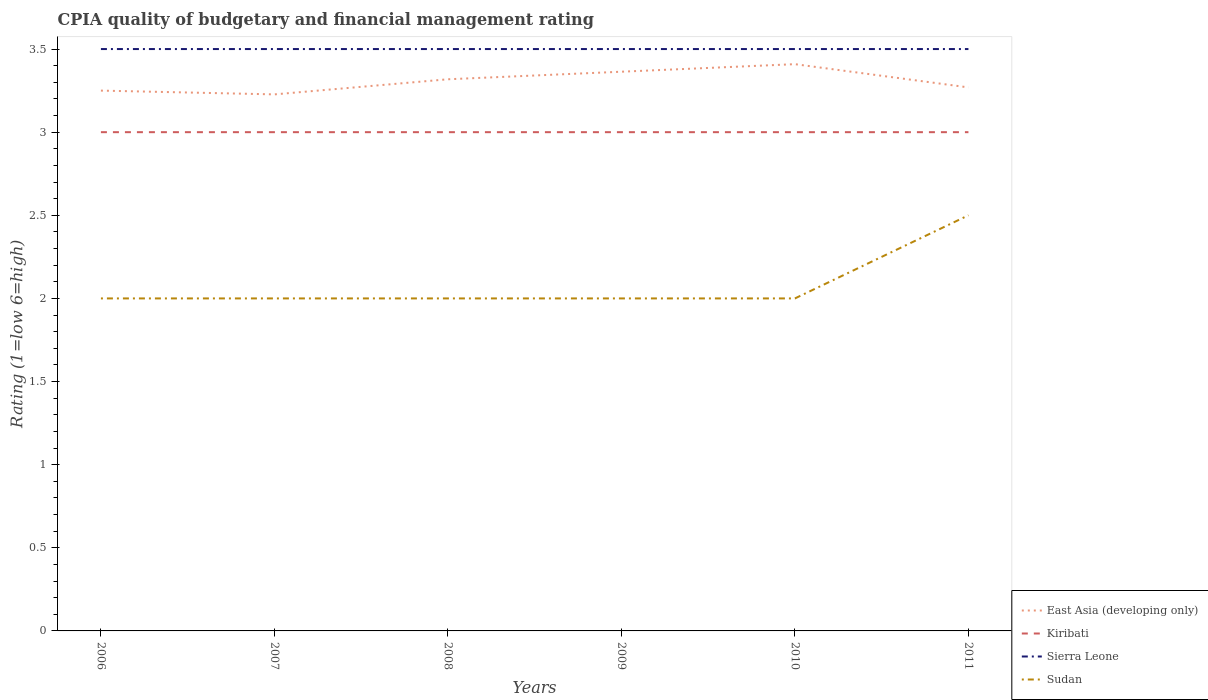What is the total CPIA rating in Sudan in the graph?
Give a very brief answer. -0.5. What is the difference between the highest and the second highest CPIA rating in East Asia (developing only)?
Offer a terse response. 0.18. What is the difference between the highest and the lowest CPIA rating in Sudan?
Your answer should be very brief. 1. How many lines are there?
Your response must be concise. 4. How many years are there in the graph?
Provide a succinct answer. 6. What is the difference between two consecutive major ticks on the Y-axis?
Your response must be concise. 0.5. Does the graph contain grids?
Your answer should be very brief. No. Where does the legend appear in the graph?
Provide a succinct answer. Bottom right. How many legend labels are there?
Offer a terse response. 4. How are the legend labels stacked?
Provide a short and direct response. Vertical. What is the title of the graph?
Provide a succinct answer. CPIA quality of budgetary and financial management rating. Does "Gambia, The" appear as one of the legend labels in the graph?
Ensure brevity in your answer.  No. What is the Rating (1=low 6=high) in Sudan in 2006?
Your answer should be compact. 2. What is the Rating (1=low 6=high) of East Asia (developing only) in 2007?
Ensure brevity in your answer.  3.23. What is the Rating (1=low 6=high) of Kiribati in 2007?
Provide a succinct answer. 3. What is the Rating (1=low 6=high) of Sierra Leone in 2007?
Make the answer very short. 3.5. What is the Rating (1=low 6=high) in East Asia (developing only) in 2008?
Offer a terse response. 3.32. What is the Rating (1=low 6=high) in Sierra Leone in 2008?
Offer a terse response. 3.5. What is the Rating (1=low 6=high) in East Asia (developing only) in 2009?
Offer a terse response. 3.36. What is the Rating (1=low 6=high) of Sierra Leone in 2009?
Offer a very short reply. 3.5. What is the Rating (1=low 6=high) of Sudan in 2009?
Provide a short and direct response. 2. What is the Rating (1=low 6=high) of East Asia (developing only) in 2010?
Offer a terse response. 3.41. What is the Rating (1=low 6=high) in Kiribati in 2010?
Make the answer very short. 3. What is the Rating (1=low 6=high) of Sudan in 2010?
Offer a very short reply. 2. What is the Rating (1=low 6=high) in East Asia (developing only) in 2011?
Offer a terse response. 3.27. What is the Rating (1=low 6=high) of Sierra Leone in 2011?
Offer a terse response. 3.5. What is the Rating (1=low 6=high) of Sudan in 2011?
Offer a terse response. 2.5. Across all years, what is the maximum Rating (1=low 6=high) of East Asia (developing only)?
Provide a short and direct response. 3.41. Across all years, what is the maximum Rating (1=low 6=high) in Sudan?
Provide a short and direct response. 2.5. Across all years, what is the minimum Rating (1=low 6=high) in East Asia (developing only)?
Offer a very short reply. 3.23. Across all years, what is the minimum Rating (1=low 6=high) of Sudan?
Your answer should be compact. 2. What is the total Rating (1=low 6=high) of East Asia (developing only) in the graph?
Your answer should be compact. 19.84. What is the difference between the Rating (1=low 6=high) of East Asia (developing only) in 2006 and that in 2007?
Provide a succinct answer. 0.02. What is the difference between the Rating (1=low 6=high) of Kiribati in 2006 and that in 2007?
Provide a short and direct response. 0. What is the difference between the Rating (1=low 6=high) of East Asia (developing only) in 2006 and that in 2008?
Offer a very short reply. -0.07. What is the difference between the Rating (1=low 6=high) in Sierra Leone in 2006 and that in 2008?
Give a very brief answer. 0. What is the difference between the Rating (1=low 6=high) of Sudan in 2006 and that in 2008?
Provide a succinct answer. 0. What is the difference between the Rating (1=low 6=high) in East Asia (developing only) in 2006 and that in 2009?
Provide a succinct answer. -0.11. What is the difference between the Rating (1=low 6=high) in Kiribati in 2006 and that in 2009?
Give a very brief answer. 0. What is the difference between the Rating (1=low 6=high) in Sierra Leone in 2006 and that in 2009?
Your answer should be compact. 0. What is the difference between the Rating (1=low 6=high) in East Asia (developing only) in 2006 and that in 2010?
Your answer should be compact. -0.16. What is the difference between the Rating (1=low 6=high) of Sierra Leone in 2006 and that in 2010?
Offer a terse response. 0. What is the difference between the Rating (1=low 6=high) of East Asia (developing only) in 2006 and that in 2011?
Your answer should be compact. -0.02. What is the difference between the Rating (1=low 6=high) of Sierra Leone in 2006 and that in 2011?
Make the answer very short. 0. What is the difference between the Rating (1=low 6=high) of Sudan in 2006 and that in 2011?
Provide a short and direct response. -0.5. What is the difference between the Rating (1=low 6=high) of East Asia (developing only) in 2007 and that in 2008?
Your answer should be compact. -0.09. What is the difference between the Rating (1=low 6=high) in East Asia (developing only) in 2007 and that in 2009?
Provide a short and direct response. -0.14. What is the difference between the Rating (1=low 6=high) of Kiribati in 2007 and that in 2009?
Your answer should be very brief. 0. What is the difference between the Rating (1=low 6=high) in East Asia (developing only) in 2007 and that in 2010?
Ensure brevity in your answer.  -0.18. What is the difference between the Rating (1=low 6=high) of Kiribati in 2007 and that in 2010?
Provide a short and direct response. 0. What is the difference between the Rating (1=low 6=high) of Sierra Leone in 2007 and that in 2010?
Offer a very short reply. 0. What is the difference between the Rating (1=low 6=high) of East Asia (developing only) in 2007 and that in 2011?
Your answer should be very brief. -0.04. What is the difference between the Rating (1=low 6=high) of East Asia (developing only) in 2008 and that in 2009?
Give a very brief answer. -0.05. What is the difference between the Rating (1=low 6=high) of Kiribati in 2008 and that in 2009?
Your answer should be very brief. 0. What is the difference between the Rating (1=low 6=high) of Sierra Leone in 2008 and that in 2009?
Make the answer very short. 0. What is the difference between the Rating (1=low 6=high) of Sudan in 2008 and that in 2009?
Give a very brief answer. 0. What is the difference between the Rating (1=low 6=high) in East Asia (developing only) in 2008 and that in 2010?
Ensure brevity in your answer.  -0.09. What is the difference between the Rating (1=low 6=high) of Kiribati in 2008 and that in 2010?
Your answer should be compact. 0. What is the difference between the Rating (1=low 6=high) of Sierra Leone in 2008 and that in 2010?
Make the answer very short. 0. What is the difference between the Rating (1=low 6=high) of Sudan in 2008 and that in 2010?
Make the answer very short. 0. What is the difference between the Rating (1=low 6=high) in East Asia (developing only) in 2008 and that in 2011?
Keep it short and to the point. 0.05. What is the difference between the Rating (1=low 6=high) of Sierra Leone in 2008 and that in 2011?
Make the answer very short. 0. What is the difference between the Rating (1=low 6=high) of East Asia (developing only) in 2009 and that in 2010?
Offer a terse response. -0.05. What is the difference between the Rating (1=low 6=high) of Kiribati in 2009 and that in 2010?
Your answer should be very brief. 0. What is the difference between the Rating (1=low 6=high) in Sierra Leone in 2009 and that in 2010?
Make the answer very short. 0. What is the difference between the Rating (1=low 6=high) in Sudan in 2009 and that in 2010?
Keep it short and to the point. 0. What is the difference between the Rating (1=low 6=high) in East Asia (developing only) in 2009 and that in 2011?
Offer a terse response. 0.09. What is the difference between the Rating (1=low 6=high) in Kiribati in 2009 and that in 2011?
Offer a very short reply. 0. What is the difference between the Rating (1=low 6=high) in Sierra Leone in 2009 and that in 2011?
Your answer should be compact. 0. What is the difference between the Rating (1=low 6=high) in East Asia (developing only) in 2010 and that in 2011?
Ensure brevity in your answer.  0.14. What is the difference between the Rating (1=low 6=high) in Kiribati in 2010 and that in 2011?
Offer a terse response. 0. What is the difference between the Rating (1=low 6=high) in Sudan in 2010 and that in 2011?
Offer a very short reply. -0.5. What is the difference between the Rating (1=low 6=high) of East Asia (developing only) in 2006 and the Rating (1=low 6=high) of Kiribati in 2007?
Offer a terse response. 0.25. What is the difference between the Rating (1=low 6=high) in East Asia (developing only) in 2006 and the Rating (1=low 6=high) in Sierra Leone in 2007?
Make the answer very short. -0.25. What is the difference between the Rating (1=low 6=high) in Kiribati in 2006 and the Rating (1=low 6=high) in Sierra Leone in 2007?
Provide a succinct answer. -0.5. What is the difference between the Rating (1=low 6=high) of Kiribati in 2006 and the Rating (1=low 6=high) of Sudan in 2007?
Make the answer very short. 1. What is the difference between the Rating (1=low 6=high) in Sierra Leone in 2006 and the Rating (1=low 6=high) in Sudan in 2007?
Provide a short and direct response. 1.5. What is the difference between the Rating (1=low 6=high) of East Asia (developing only) in 2006 and the Rating (1=low 6=high) of Kiribati in 2008?
Offer a very short reply. 0.25. What is the difference between the Rating (1=low 6=high) of Kiribati in 2006 and the Rating (1=low 6=high) of Sierra Leone in 2008?
Provide a succinct answer. -0.5. What is the difference between the Rating (1=low 6=high) in Kiribati in 2006 and the Rating (1=low 6=high) in Sudan in 2008?
Keep it short and to the point. 1. What is the difference between the Rating (1=low 6=high) in Sierra Leone in 2006 and the Rating (1=low 6=high) in Sudan in 2008?
Provide a short and direct response. 1.5. What is the difference between the Rating (1=low 6=high) in East Asia (developing only) in 2006 and the Rating (1=low 6=high) in Kiribati in 2009?
Provide a short and direct response. 0.25. What is the difference between the Rating (1=low 6=high) in East Asia (developing only) in 2006 and the Rating (1=low 6=high) in Sierra Leone in 2009?
Provide a succinct answer. -0.25. What is the difference between the Rating (1=low 6=high) of Sierra Leone in 2006 and the Rating (1=low 6=high) of Sudan in 2009?
Ensure brevity in your answer.  1.5. What is the difference between the Rating (1=low 6=high) in East Asia (developing only) in 2006 and the Rating (1=low 6=high) in Kiribati in 2010?
Provide a short and direct response. 0.25. What is the difference between the Rating (1=low 6=high) of East Asia (developing only) in 2006 and the Rating (1=low 6=high) of Sudan in 2010?
Your response must be concise. 1.25. What is the difference between the Rating (1=low 6=high) of Kiribati in 2006 and the Rating (1=low 6=high) of Sierra Leone in 2010?
Your answer should be compact. -0.5. What is the difference between the Rating (1=low 6=high) of East Asia (developing only) in 2006 and the Rating (1=low 6=high) of Sierra Leone in 2011?
Offer a terse response. -0.25. What is the difference between the Rating (1=low 6=high) in East Asia (developing only) in 2006 and the Rating (1=low 6=high) in Sudan in 2011?
Ensure brevity in your answer.  0.75. What is the difference between the Rating (1=low 6=high) of Kiribati in 2006 and the Rating (1=low 6=high) of Sudan in 2011?
Offer a terse response. 0.5. What is the difference between the Rating (1=low 6=high) of Sierra Leone in 2006 and the Rating (1=low 6=high) of Sudan in 2011?
Give a very brief answer. 1. What is the difference between the Rating (1=low 6=high) in East Asia (developing only) in 2007 and the Rating (1=low 6=high) in Kiribati in 2008?
Offer a very short reply. 0.23. What is the difference between the Rating (1=low 6=high) in East Asia (developing only) in 2007 and the Rating (1=low 6=high) in Sierra Leone in 2008?
Your response must be concise. -0.27. What is the difference between the Rating (1=low 6=high) of East Asia (developing only) in 2007 and the Rating (1=low 6=high) of Sudan in 2008?
Your response must be concise. 1.23. What is the difference between the Rating (1=low 6=high) of East Asia (developing only) in 2007 and the Rating (1=low 6=high) of Kiribati in 2009?
Your answer should be compact. 0.23. What is the difference between the Rating (1=low 6=high) in East Asia (developing only) in 2007 and the Rating (1=low 6=high) in Sierra Leone in 2009?
Give a very brief answer. -0.27. What is the difference between the Rating (1=low 6=high) of East Asia (developing only) in 2007 and the Rating (1=low 6=high) of Sudan in 2009?
Your answer should be compact. 1.23. What is the difference between the Rating (1=low 6=high) in Kiribati in 2007 and the Rating (1=low 6=high) in Sierra Leone in 2009?
Your answer should be very brief. -0.5. What is the difference between the Rating (1=low 6=high) in East Asia (developing only) in 2007 and the Rating (1=low 6=high) in Kiribati in 2010?
Provide a succinct answer. 0.23. What is the difference between the Rating (1=low 6=high) in East Asia (developing only) in 2007 and the Rating (1=low 6=high) in Sierra Leone in 2010?
Your response must be concise. -0.27. What is the difference between the Rating (1=low 6=high) of East Asia (developing only) in 2007 and the Rating (1=low 6=high) of Sudan in 2010?
Offer a terse response. 1.23. What is the difference between the Rating (1=low 6=high) in Sierra Leone in 2007 and the Rating (1=low 6=high) in Sudan in 2010?
Keep it short and to the point. 1.5. What is the difference between the Rating (1=low 6=high) in East Asia (developing only) in 2007 and the Rating (1=low 6=high) in Kiribati in 2011?
Keep it short and to the point. 0.23. What is the difference between the Rating (1=low 6=high) of East Asia (developing only) in 2007 and the Rating (1=low 6=high) of Sierra Leone in 2011?
Your response must be concise. -0.27. What is the difference between the Rating (1=low 6=high) of East Asia (developing only) in 2007 and the Rating (1=low 6=high) of Sudan in 2011?
Your answer should be very brief. 0.73. What is the difference between the Rating (1=low 6=high) of Kiribati in 2007 and the Rating (1=low 6=high) of Sudan in 2011?
Give a very brief answer. 0.5. What is the difference between the Rating (1=low 6=high) in Sierra Leone in 2007 and the Rating (1=low 6=high) in Sudan in 2011?
Your answer should be compact. 1. What is the difference between the Rating (1=low 6=high) of East Asia (developing only) in 2008 and the Rating (1=low 6=high) of Kiribati in 2009?
Your answer should be very brief. 0.32. What is the difference between the Rating (1=low 6=high) in East Asia (developing only) in 2008 and the Rating (1=low 6=high) in Sierra Leone in 2009?
Make the answer very short. -0.18. What is the difference between the Rating (1=low 6=high) of East Asia (developing only) in 2008 and the Rating (1=low 6=high) of Sudan in 2009?
Offer a very short reply. 1.32. What is the difference between the Rating (1=low 6=high) of Kiribati in 2008 and the Rating (1=low 6=high) of Sudan in 2009?
Your answer should be compact. 1. What is the difference between the Rating (1=low 6=high) of East Asia (developing only) in 2008 and the Rating (1=low 6=high) of Kiribati in 2010?
Give a very brief answer. 0.32. What is the difference between the Rating (1=low 6=high) of East Asia (developing only) in 2008 and the Rating (1=low 6=high) of Sierra Leone in 2010?
Give a very brief answer. -0.18. What is the difference between the Rating (1=low 6=high) in East Asia (developing only) in 2008 and the Rating (1=low 6=high) in Sudan in 2010?
Make the answer very short. 1.32. What is the difference between the Rating (1=low 6=high) of Kiribati in 2008 and the Rating (1=low 6=high) of Sierra Leone in 2010?
Make the answer very short. -0.5. What is the difference between the Rating (1=low 6=high) in East Asia (developing only) in 2008 and the Rating (1=low 6=high) in Kiribati in 2011?
Provide a short and direct response. 0.32. What is the difference between the Rating (1=low 6=high) in East Asia (developing only) in 2008 and the Rating (1=low 6=high) in Sierra Leone in 2011?
Make the answer very short. -0.18. What is the difference between the Rating (1=low 6=high) of East Asia (developing only) in 2008 and the Rating (1=low 6=high) of Sudan in 2011?
Provide a short and direct response. 0.82. What is the difference between the Rating (1=low 6=high) of Kiribati in 2008 and the Rating (1=low 6=high) of Sierra Leone in 2011?
Your answer should be very brief. -0.5. What is the difference between the Rating (1=low 6=high) of East Asia (developing only) in 2009 and the Rating (1=low 6=high) of Kiribati in 2010?
Give a very brief answer. 0.36. What is the difference between the Rating (1=low 6=high) of East Asia (developing only) in 2009 and the Rating (1=low 6=high) of Sierra Leone in 2010?
Keep it short and to the point. -0.14. What is the difference between the Rating (1=low 6=high) in East Asia (developing only) in 2009 and the Rating (1=low 6=high) in Sudan in 2010?
Your response must be concise. 1.36. What is the difference between the Rating (1=low 6=high) in Kiribati in 2009 and the Rating (1=low 6=high) in Sierra Leone in 2010?
Offer a very short reply. -0.5. What is the difference between the Rating (1=low 6=high) in Sierra Leone in 2009 and the Rating (1=low 6=high) in Sudan in 2010?
Provide a succinct answer. 1.5. What is the difference between the Rating (1=low 6=high) in East Asia (developing only) in 2009 and the Rating (1=low 6=high) in Kiribati in 2011?
Your response must be concise. 0.36. What is the difference between the Rating (1=low 6=high) in East Asia (developing only) in 2009 and the Rating (1=low 6=high) in Sierra Leone in 2011?
Make the answer very short. -0.14. What is the difference between the Rating (1=low 6=high) of East Asia (developing only) in 2009 and the Rating (1=low 6=high) of Sudan in 2011?
Your response must be concise. 0.86. What is the difference between the Rating (1=low 6=high) of Kiribati in 2009 and the Rating (1=low 6=high) of Sudan in 2011?
Offer a terse response. 0.5. What is the difference between the Rating (1=low 6=high) in Sierra Leone in 2009 and the Rating (1=low 6=high) in Sudan in 2011?
Your response must be concise. 1. What is the difference between the Rating (1=low 6=high) in East Asia (developing only) in 2010 and the Rating (1=low 6=high) in Kiribati in 2011?
Ensure brevity in your answer.  0.41. What is the difference between the Rating (1=low 6=high) in East Asia (developing only) in 2010 and the Rating (1=low 6=high) in Sierra Leone in 2011?
Your response must be concise. -0.09. What is the difference between the Rating (1=low 6=high) of East Asia (developing only) in 2010 and the Rating (1=low 6=high) of Sudan in 2011?
Your answer should be very brief. 0.91. What is the difference between the Rating (1=low 6=high) in Kiribati in 2010 and the Rating (1=low 6=high) in Sierra Leone in 2011?
Offer a very short reply. -0.5. What is the difference between the Rating (1=low 6=high) in Kiribati in 2010 and the Rating (1=low 6=high) in Sudan in 2011?
Make the answer very short. 0.5. What is the average Rating (1=low 6=high) in East Asia (developing only) per year?
Offer a terse response. 3.31. What is the average Rating (1=low 6=high) in Sierra Leone per year?
Your answer should be very brief. 3.5. What is the average Rating (1=low 6=high) in Sudan per year?
Your answer should be very brief. 2.08. In the year 2006, what is the difference between the Rating (1=low 6=high) of East Asia (developing only) and Rating (1=low 6=high) of Sierra Leone?
Offer a very short reply. -0.25. In the year 2006, what is the difference between the Rating (1=low 6=high) in Kiribati and Rating (1=low 6=high) in Sudan?
Your answer should be compact. 1. In the year 2006, what is the difference between the Rating (1=low 6=high) in Sierra Leone and Rating (1=low 6=high) in Sudan?
Your answer should be very brief. 1.5. In the year 2007, what is the difference between the Rating (1=low 6=high) of East Asia (developing only) and Rating (1=low 6=high) of Kiribati?
Offer a terse response. 0.23. In the year 2007, what is the difference between the Rating (1=low 6=high) in East Asia (developing only) and Rating (1=low 6=high) in Sierra Leone?
Offer a very short reply. -0.27. In the year 2007, what is the difference between the Rating (1=low 6=high) in East Asia (developing only) and Rating (1=low 6=high) in Sudan?
Provide a succinct answer. 1.23. In the year 2007, what is the difference between the Rating (1=low 6=high) of Kiribati and Rating (1=low 6=high) of Sudan?
Give a very brief answer. 1. In the year 2007, what is the difference between the Rating (1=low 6=high) of Sierra Leone and Rating (1=low 6=high) of Sudan?
Offer a terse response. 1.5. In the year 2008, what is the difference between the Rating (1=low 6=high) in East Asia (developing only) and Rating (1=low 6=high) in Kiribati?
Make the answer very short. 0.32. In the year 2008, what is the difference between the Rating (1=low 6=high) in East Asia (developing only) and Rating (1=low 6=high) in Sierra Leone?
Ensure brevity in your answer.  -0.18. In the year 2008, what is the difference between the Rating (1=low 6=high) in East Asia (developing only) and Rating (1=low 6=high) in Sudan?
Ensure brevity in your answer.  1.32. In the year 2008, what is the difference between the Rating (1=low 6=high) of Kiribati and Rating (1=low 6=high) of Sudan?
Ensure brevity in your answer.  1. In the year 2009, what is the difference between the Rating (1=low 6=high) of East Asia (developing only) and Rating (1=low 6=high) of Kiribati?
Ensure brevity in your answer.  0.36. In the year 2009, what is the difference between the Rating (1=low 6=high) of East Asia (developing only) and Rating (1=low 6=high) of Sierra Leone?
Keep it short and to the point. -0.14. In the year 2009, what is the difference between the Rating (1=low 6=high) of East Asia (developing only) and Rating (1=low 6=high) of Sudan?
Your response must be concise. 1.36. In the year 2009, what is the difference between the Rating (1=low 6=high) of Sierra Leone and Rating (1=low 6=high) of Sudan?
Make the answer very short. 1.5. In the year 2010, what is the difference between the Rating (1=low 6=high) in East Asia (developing only) and Rating (1=low 6=high) in Kiribati?
Provide a short and direct response. 0.41. In the year 2010, what is the difference between the Rating (1=low 6=high) in East Asia (developing only) and Rating (1=low 6=high) in Sierra Leone?
Offer a very short reply. -0.09. In the year 2010, what is the difference between the Rating (1=low 6=high) in East Asia (developing only) and Rating (1=low 6=high) in Sudan?
Give a very brief answer. 1.41. In the year 2010, what is the difference between the Rating (1=low 6=high) of Kiribati and Rating (1=low 6=high) of Sudan?
Make the answer very short. 1. In the year 2010, what is the difference between the Rating (1=low 6=high) of Sierra Leone and Rating (1=low 6=high) of Sudan?
Your response must be concise. 1.5. In the year 2011, what is the difference between the Rating (1=low 6=high) of East Asia (developing only) and Rating (1=low 6=high) of Kiribati?
Make the answer very short. 0.27. In the year 2011, what is the difference between the Rating (1=low 6=high) of East Asia (developing only) and Rating (1=low 6=high) of Sierra Leone?
Keep it short and to the point. -0.23. In the year 2011, what is the difference between the Rating (1=low 6=high) in East Asia (developing only) and Rating (1=low 6=high) in Sudan?
Provide a succinct answer. 0.77. In the year 2011, what is the difference between the Rating (1=low 6=high) of Kiribati and Rating (1=low 6=high) of Sierra Leone?
Your response must be concise. -0.5. In the year 2011, what is the difference between the Rating (1=low 6=high) in Kiribati and Rating (1=low 6=high) in Sudan?
Provide a short and direct response. 0.5. What is the ratio of the Rating (1=low 6=high) of Kiribati in 2006 to that in 2007?
Provide a succinct answer. 1. What is the ratio of the Rating (1=low 6=high) of Sierra Leone in 2006 to that in 2007?
Offer a terse response. 1. What is the ratio of the Rating (1=low 6=high) of East Asia (developing only) in 2006 to that in 2008?
Offer a terse response. 0.98. What is the ratio of the Rating (1=low 6=high) in Sierra Leone in 2006 to that in 2008?
Ensure brevity in your answer.  1. What is the ratio of the Rating (1=low 6=high) of East Asia (developing only) in 2006 to that in 2009?
Your answer should be very brief. 0.97. What is the ratio of the Rating (1=low 6=high) in Kiribati in 2006 to that in 2009?
Make the answer very short. 1. What is the ratio of the Rating (1=low 6=high) of East Asia (developing only) in 2006 to that in 2010?
Provide a short and direct response. 0.95. What is the ratio of the Rating (1=low 6=high) in Sudan in 2006 to that in 2010?
Provide a succinct answer. 1. What is the ratio of the Rating (1=low 6=high) in Kiribati in 2006 to that in 2011?
Make the answer very short. 1. What is the ratio of the Rating (1=low 6=high) in Sierra Leone in 2006 to that in 2011?
Ensure brevity in your answer.  1. What is the ratio of the Rating (1=low 6=high) in East Asia (developing only) in 2007 to that in 2008?
Provide a succinct answer. 0.97. What is the ratio of the Rating (1=low 6=high) in Sierra Leone in 2007 to that in 2008?
Offer a very short reply. 1. What is the ratio of the Rating (1=low 6=high) of Sudan in 2007 to that in 2008?
Give a very brief answer. 1. What is the ratio of the Rating (1=low 6=high) in East Asia (developing only) in 2007 to that in 2009?
Ensure brevity in your answer.  0.96. What is the ratio of the Rating (1=low 6=high) of Kiribati in 2007 to that in 2009?
Offer a very short reply. 1. What is the ratio of the Rating (1=low 6=high) of East Asia (developing only) in 2007 to that in 2010?
Give a very brief answer. 0.95. What is the ratio of the Rating (1=low 6=high) of Sudan in 2007 to that in 2010?
Your response must be concise. 1. What is the ratio of the Rating (1=low 6=high) in East Asia (developing only) in 2007 to that in 2011?
Your answer should be compact. 0.99. What is the ratio of the Rating (1=low 6=high) of Sierra Leone in 2007 to that in 2011?
Provide a short and direct response. 1. What is the ratio of the Rating (1=low 6=high) of Sudan in 2007 to that in 2011?
Your answer should be compact. 0.8. What is the ratio of the Rating (1=low 6=high) of East Asia (developing only) in 2008 to that in 2009?
Keep it short and to the point. 0.99. What is the ratio of the Rating (1=low 6=high) in Kiribati in 2008 to that in 2009?
Your answer should be very brief. 1. What is the ratio of the Rating (1=low 6=high) in East Asia (developing only) in 2008 to that in 2010?
Your answer should be compact. 0.97. What is the ratio of the Rating (1=low 6=high) in Sierra Leone in 2008 to that in 2010?
Your answer should be compact. 1. What is the ratio of the Rating (1=low 6=high) of Sudan in 2008 to that in 2010?
Keep it short and to the point. 1. What is the ratio of the Rating (1=low 6=high) of Sierra Leone in 2008 to that in 2011?
Keep it short and to the point. 1. What is the ratio of the Rating (1=low 6=high) in Sudan in 2008 to that in 2011?
Offer a terse response. 0.8. What is the ratio of the Rating (1=low 6=high) of East Asia (developing only) in 2009 to that in 2010?
Ensure brevity in your answer.  0.99. What is the ratio of the Rating (1=low 6=high) of Sierra Leone in 2009 to that in 2010?
Your answer should be compact. 1. What is the ratio of the Rating (1=low 6=high) of Sudan in 2009 to that in 2010?
Provide a short and direct response. 1. What is the ratio of the Rating (1=low 6=high) of East Asia (developing only) in 2009 to that in 2011?
Provide a short and direct response. 1.03. What is the ratio of the Rating (1=low 6=high) in Sierra Leone in 2009 to that in 2011?
Provide a short and direct response. 1. What is the ratio of the Rating (1=low 6=high) of East Asia (developing only) in 2010 to that in 2011?
Your answer should be very brief. 1.04. What is the ratio of the Rating (1=low 6=high) of Kiribati in 2010 to that in 2011?
Make the answer very short. 1. What is the ratio of the Rating (1=low 6=high) of Sierra Leone in 2010 to that in 2011?
Provide a short and direct response. 1. What is the ratio of the Rating (1=low 6=high) in Sudan in 2010 to that in 2011?
Your answer should be very brief. 0.8. What is the difference between the highest and the second highest Rating (1=low 6=high) of East Asia (developing only)?
Give a very brief answer. 0.05. What is the difference between the highest and the second highest Rating (1=low 6=high) of Sierra Leone?
Your answer should be very brief. 0. What is the difference between the highest and the lowest Rating (1=low 6=high) of East Asia (developing only)?
Provide a succinct answer. 0.18. What is the difference between the highest and the lowest Rating (1=low 6=high) of Sudan?
Offer a very short reply. 0.5. 